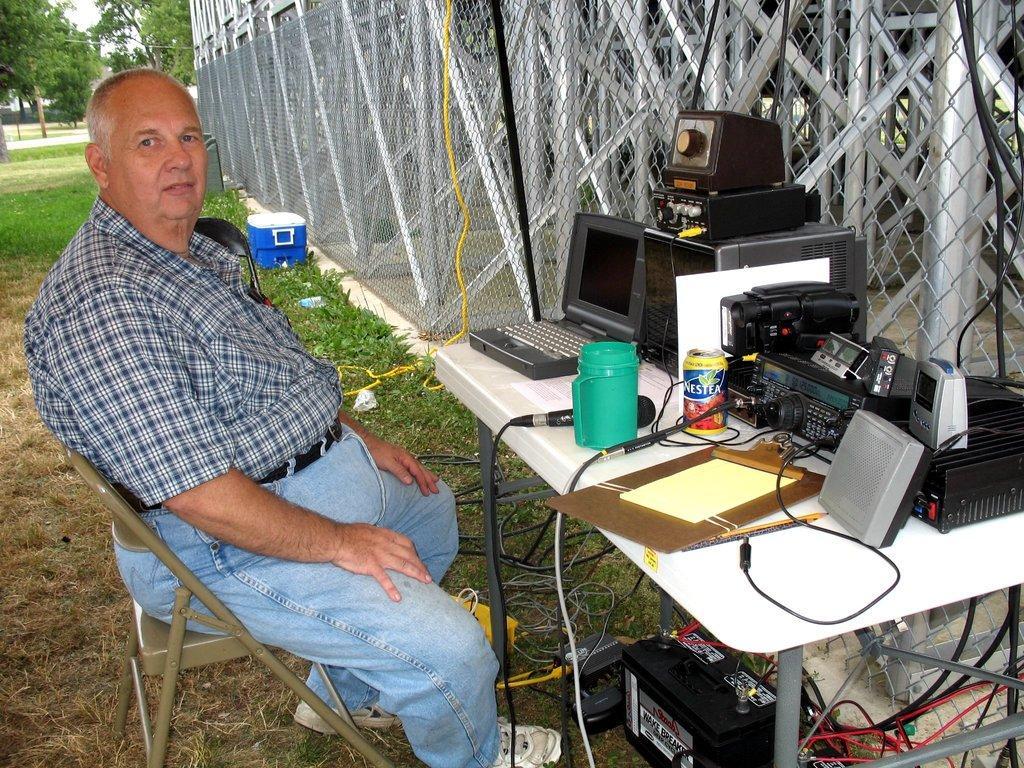Could you give a brief overview of what you see in this image? In the image we can see a man sitting on a chair. In front of him there is a table, system, microphone, water jug, can and gadget. This is a iron fencing and there are many tree and white sky. 